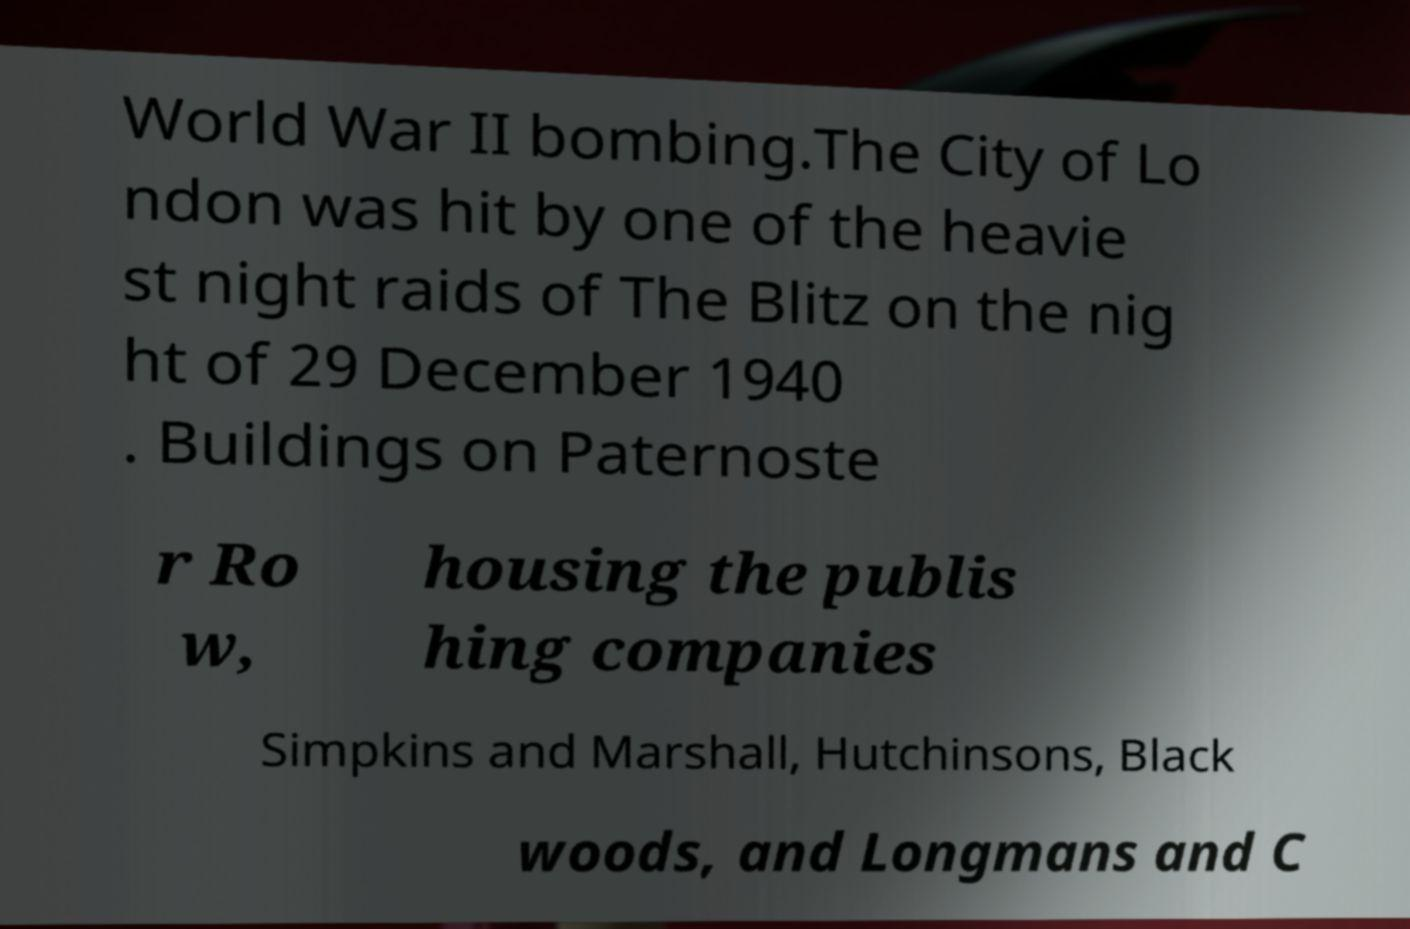I need the written content from this picture converted into text. Can you do that? World War II bombing.The City of Lo ndon was hit by one of the heavie st night raids of The Blitz on the nig ht of 29 December 1940 . Buildings on Paternoste r Ro w, housing the publis hing companies Simpkins and Marshall, Hutchinsons, Black woods, and Longmans and C 